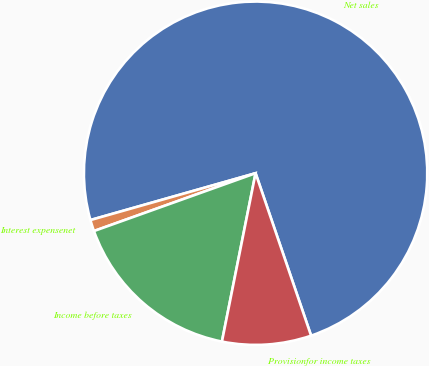Convert chart to OTSL. <chart><loc_0><loc_0><loc_500><loc_500><pie_chart><fcel>Net sales<fcel>Interest expensenet<fcel>Income before taxes<fcel>Provisionfor income taxes<nl><fcel>74.15%<fcel>1.07%<fcel>16.39%<fcel>8.38%<nl></chart> 